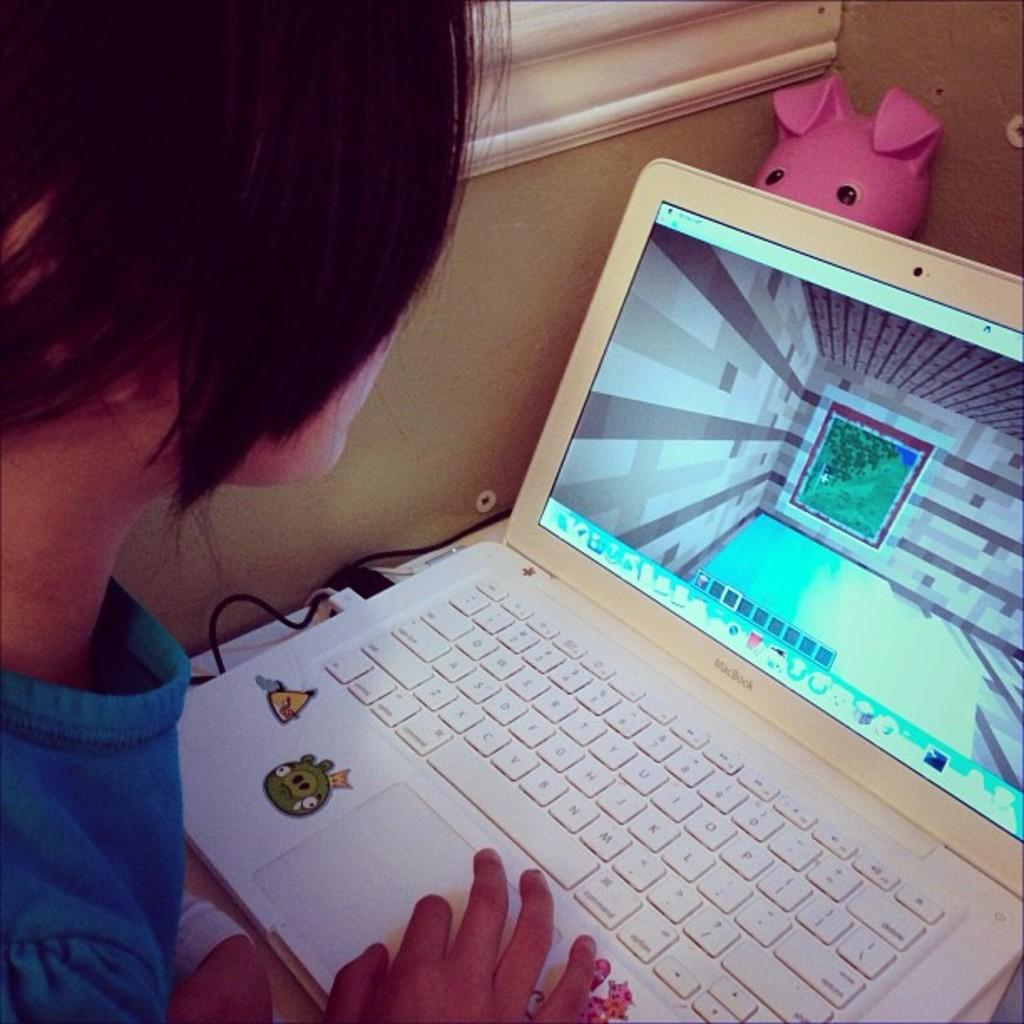Who or what is present in the image? There is a person in the image. What electronic device can be seen in the image? There is a laptop in the image. Are there any toys visible in the image? Yes, there is a toy in the image. What type of object is present that might be used for connecting devices? There is a wire in the image. What architectural feature is present in the image? There is a window and a wall in the image. Can you describe the setting of the image? The image is likely taken in a room. What type of fork can be seen in the image? There is no fork present in the image. 